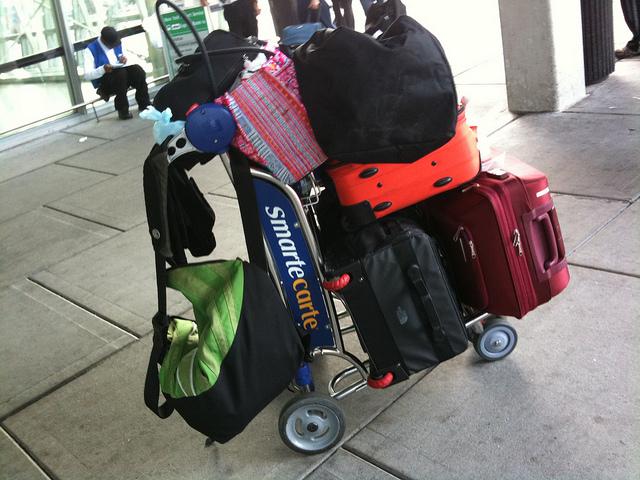Is the red bag securely closed?
Answer briefly. Yes. What word comes before "carte"?
Quick response, please. Smarter. Is someone using this luggage cart?
Short answer required. Yes. What is in the luggage cart?
Be succinct. Luggage. How many tiles are on the floor?
Write a very short answer. Many. How many bags appear on the cart?
Be succinct. 7. 